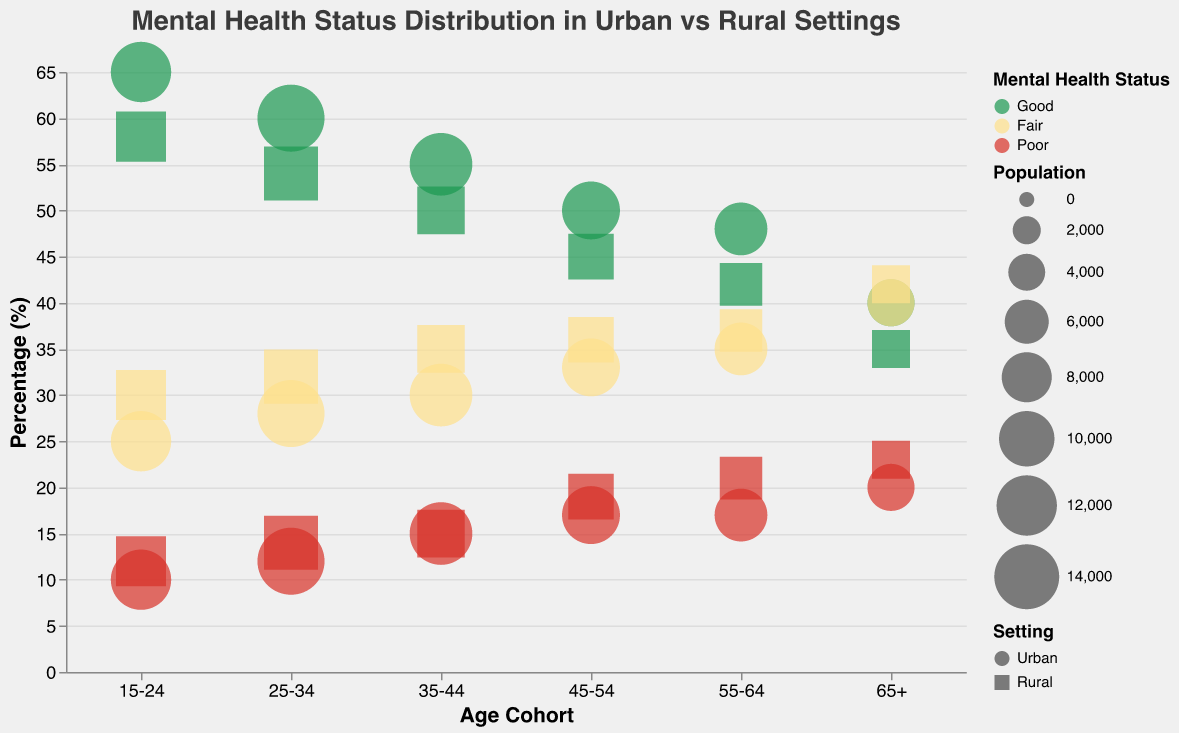What is the title of the chart? The title of the chart is mentioned at the top and reads "Mental Health Status Distribution in Urban vs Rural Settings".
Answer: Mental Health Status Distribution in Urban vs Rural Settings Which age cohort has the highest percentage of good mental health status in Urban settings? By observing the chart, the age cohort with the highest percentage of good mental health status in Urban settings appears to be the "15-24" group with approximately 65%.
Answer: 15-24 What is the difference in percentage of those with poor mental health status between Urban and Rural settings for the age cohort 45-54? For the 45-54 age cohort, the percentage for poor mental health status in Urban settings is 17%, while in Rural settings it is 19%. The difference is 19% - 17% = 2%.
Answer: 2% How does the mental health status of the 65+ age cohort compare between Urban and Rural settings? In the Urban setting, the percentages for good, fair, and poor mental health status for the 65+ age cohort are 40%, 40%, and 20% respectively. In Rural settings, these percentages are 35%, 42%, and 23%. Compared to Urban settings, Rural settings have lower good mental health (35% vs 40%), slightly higher fair mental health (42% vs 40%), and higher poor mental health (23% vs 20%).
Answer: Good: -5%, Fair: +2%, Poor: +3% What's the overall pattern of good mental health status among different age cohorts for Urban settings? The overall pattern indicates that the percentage of people with good mental health status decreases with age in Urban settings, starting from 65% in the 15-24 age cohort down to 40% in the 65+ age cohort.
Answer: Decreases with age Compare the Variation in Fair mental health status of Rural settings between the youngest and oldest age cohorts. For the 15-24 cohort in Rural settings, the percentage is 30% for fair mental health status. For the 65+ cohort, the percentage is 42%. The variation in percentage is 42% - 30% = 12%.
Answer: 12% Which age cohort has the largest population in Urban settings based on bubble size? By observing the size of the bubbles representing the population in Urban settings, the age cohort 25-34 has the largest population with a total of 15,000 people.
Answer: 25-34 How does the good mental health status percentage for the age cohort 35-44 compare between Urban and Rural settings? The urban percentage for good mental health status in the 35-44 cohort is 55%, while in rural settings it is 50%. Hence, urban settings have a 5% higher percentage for this age cohort.
Answer: 5% Higher What's the trend in poor mental health status moving from younger to older age cohorts in Rural settings? Observing the chart, the percentage of poor mental health status in rural settings increases from 12% in the 15-24 cohort to 23% in the 65+ cohort.
Answer: Increases 